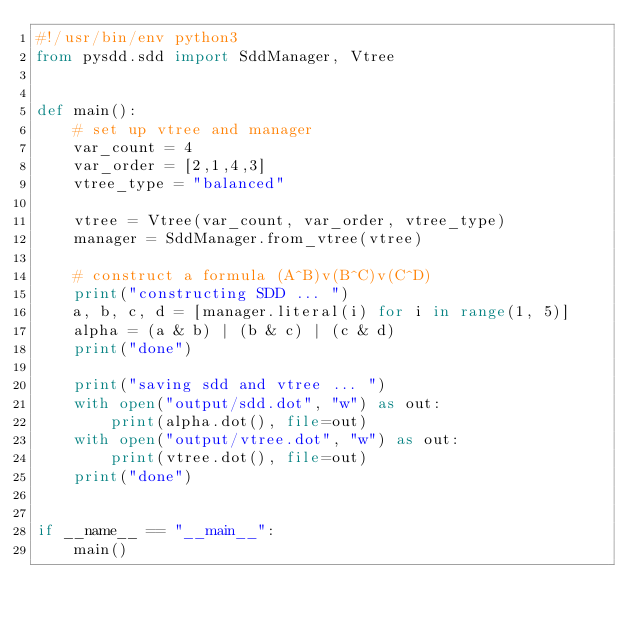Convert code to text. <code><loc_0><loc_0><loc_500><loc_500><_Python_>#!/usr/bin/env python3
from pysdd.sdd import SddManager, Vtree


def main():
    # set up vtree and manager
    var_count = 4
    var_order = [2,1,4,3]
    vtree_type = "balanced"

    vtree = Vtree(var_count, var_order, vtree_type)
    manager = SddManager.from_vtree(vtree)

    # construct a formula (A^B)v(B^C)v(C^D)
    print("constructing SDD ... ")
    a, b, c, d = [manager.literal(i) for i in range(1, 5)]
    alpha = (a & b) | (b & c) | (c & d)
    print("done")

    print("saving sdd and vtree ... ")
    with open("output/sdd.dot", "w") as out:
        print(alpha.dot(), file=out)
    with open("output/vtree.dot", "w") as out:
        print(vtree.dot(), file=out)
    print("done")


if __name__ == "__main__":
    main()

</code> 